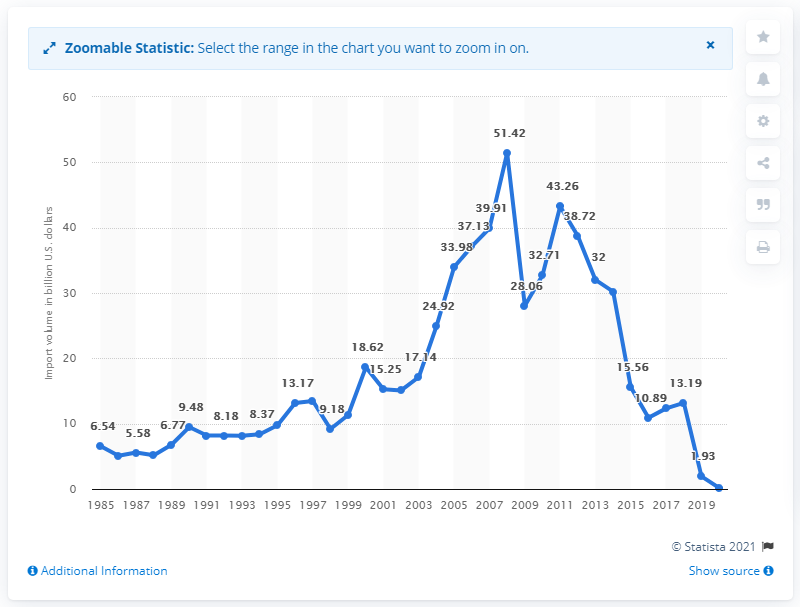List a handful of essential elements in this visual. In 2020, the United States imported a total of $0.17 from Venezuela. 